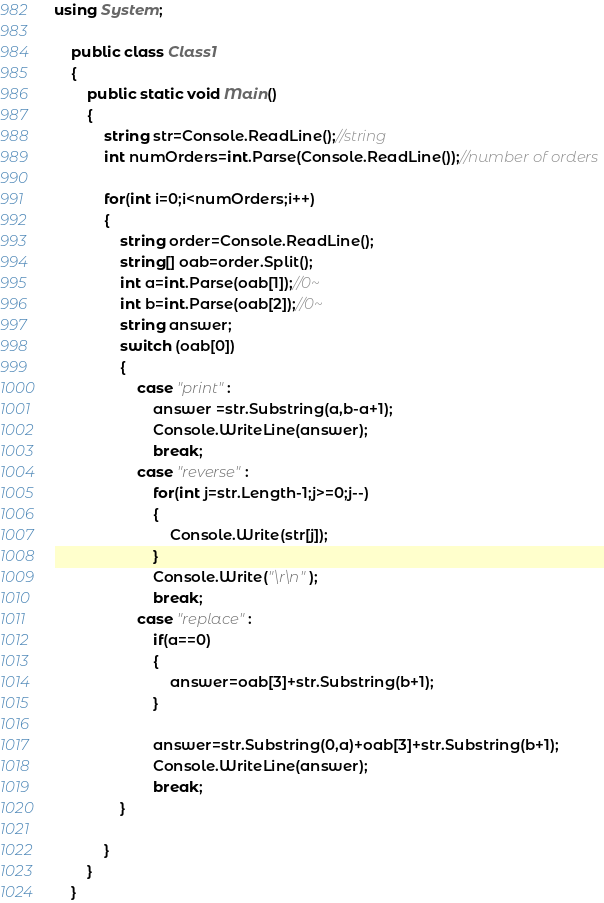Convert code to text. <code><loc_0><loc_0><loc_500><loc_500><_C#_>
using System;

	public class Class1
	{
		public static void Main()
		{  
			string str=Console.ReadLine();//string
			int numOrders=int.Parse(Console.ReadLine());//number of orders
			
			for(int i=0;i<numOrders;i++)
			{
				string order=Console.ReadLine();
				string[] oab=order.Split();
				int a=int.Parse(oab[1]);//0~
				int b=int.Parse(oab[2]);//0~
				string answer;
				switch (oab[0])
				{
					case "print":
						answer =str.Substring(a,b-a+1);
						Console.WriteLine(answer);
						break;
					case "reverse":
						for(int j=str.Length-1;j>=0;j--)
						{
							Console.Write(str[j]);	
						}
						Console.Write("\r\n");
						break;
					case "replace":
						if(a==0)
						{
							answer=oab[3]+str.Substring(b+1);
						}
											
						answer=str.Substring(0,a)+oab[3]+str.Substring(b+1);
						Console.WriteLine(answer);
						break;
				}
					
			}
		}
	}</code> 